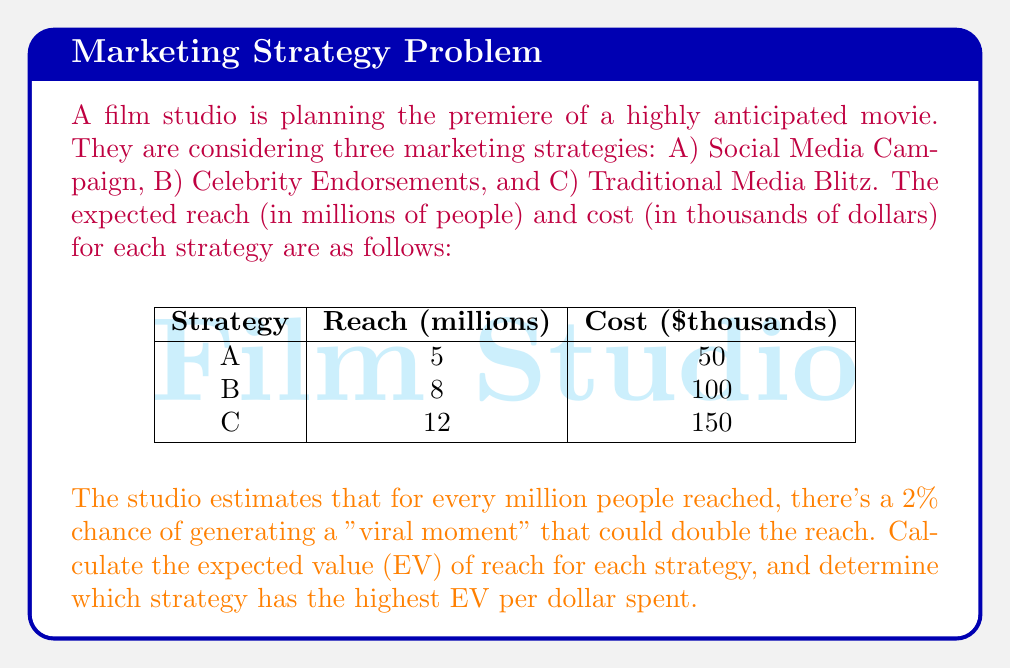What is the answer to this math problem? Let's approach this problem step-by-step:

1) First, we need to calculate the probability of generating a viral moment for each strategy:

   Strategy A: $P(viral)_A = 5 \times 0.02 = 0.10$ or 10%
   Strategy B: $P(viral)_B = 8 \times 0.02 = 0.16$ or 16%
   Strategy C: $P(viral)_C = 12 \times 0.02 = 0.24$ or 24%

2) Now, let's calculate the expected reach for each strategy:

   Strategy A: 
   $EV(A) = 0.90 \times 5 + 0.10 \times (2 \times 5) = 4.5 + 1 = 5.5$ million

   Strategy B:
   $EV(B) = 0.84 \times 8 + 0.16 \times (2 \times 8) = 6.72 + 2.56 = 9.28$ million

   Strategy C:
   $EV(C) = 0.76 \times 12 + 0.24 \times (2 \times 12) = 9.12 + 5.76 = 14.88$ million

3) To determine which strategy has the highest EV per dollar spent, we need to divide the expected reach by the cost:

   Strategy A: $\frac{5.5}{50} = 0.11$ million per thousand dollars
   Strategy B: $\frac{9.28}{100} = 0.0928$ million per thousand dollars
   Strategy C: $\frac{14.88}{150} = 0.0992$ million per thousand dollars
Answer: The expected values of reach for strategies A, B, and C are 5.5 million, 9.28 million, and 14.88 million respectively. Strategy A has the highest EV per dollar spent at 0.11 million per thousand dollars. 